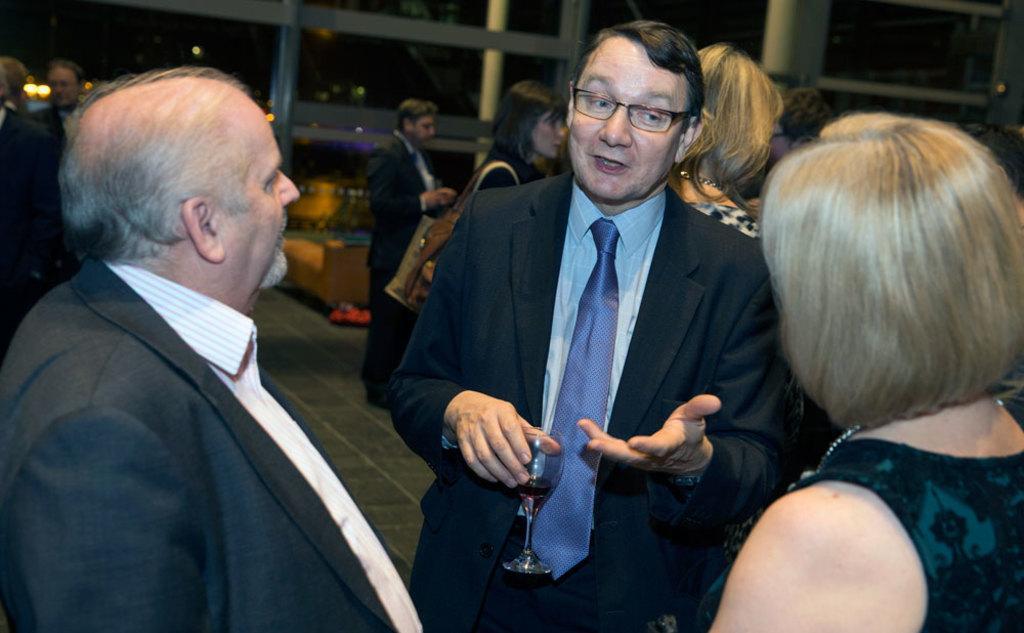In one or two sentences, can you explain what this image depicts? In this image there are persons standing. In the background there are pillars and there are windows and there is an empty sofa and there is an object which is red in colour on the floor. In the front there is a person standing and holding a glass in his hand and speaking. 